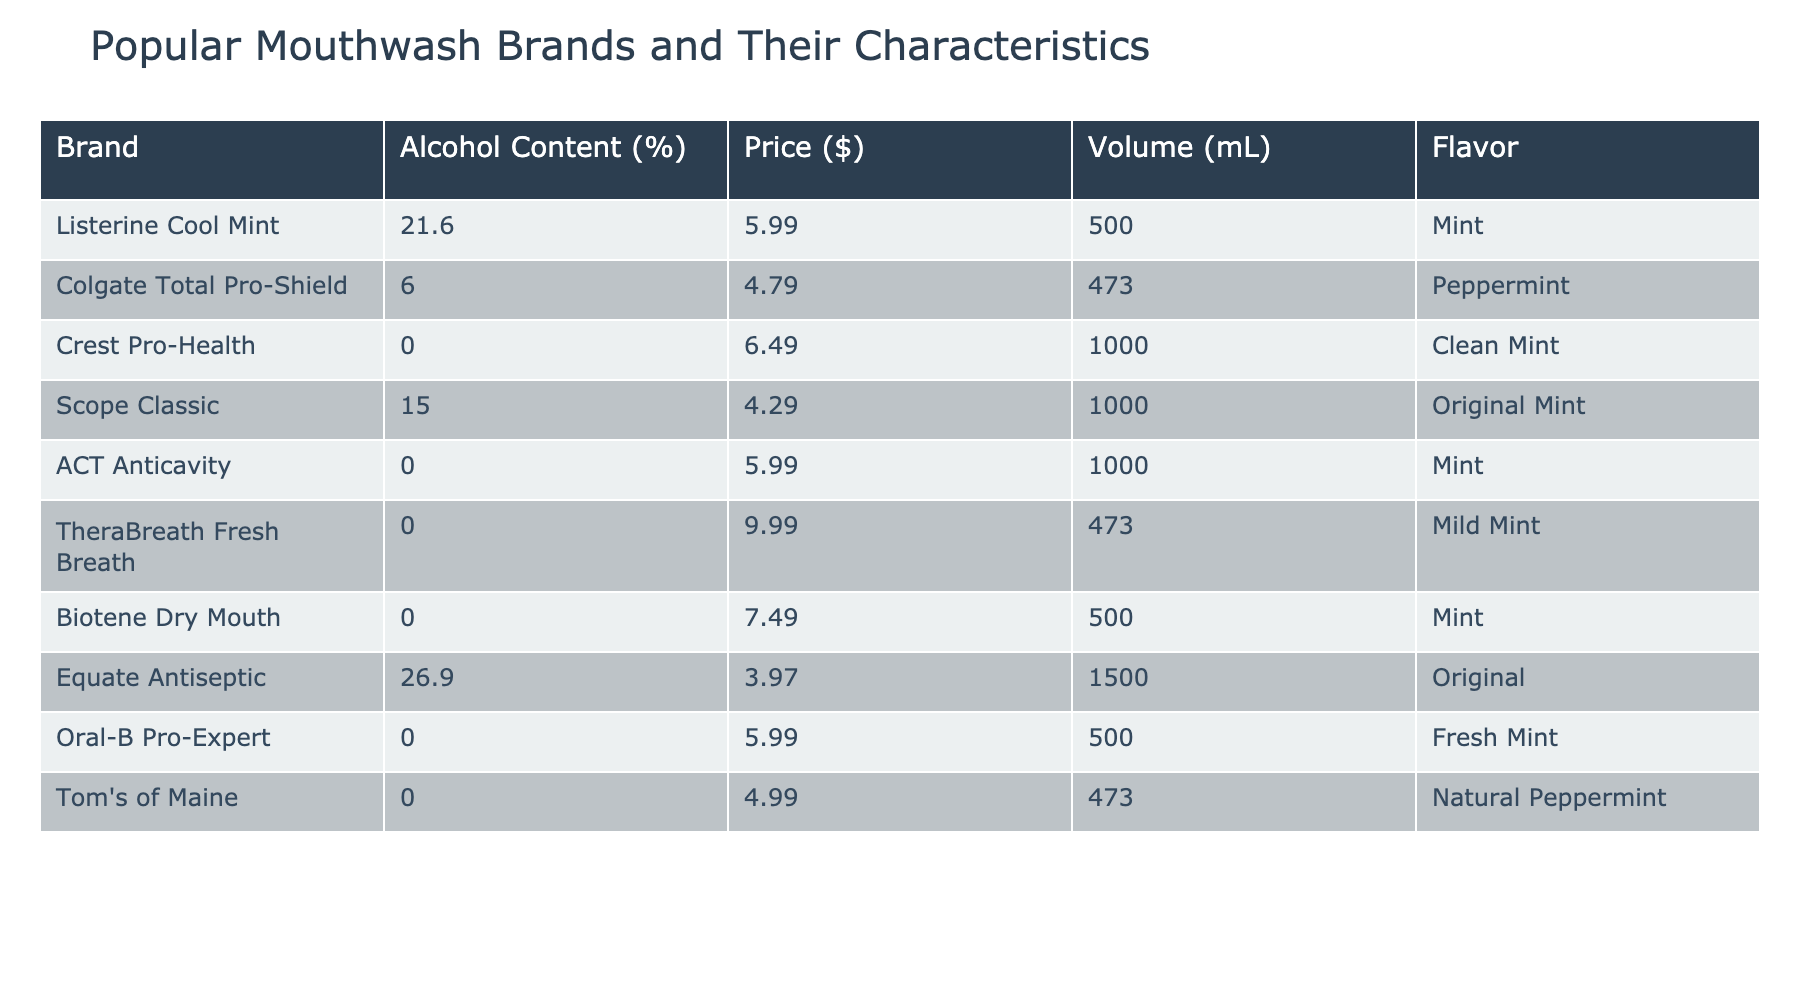What is the alcohol content of Listerine Cool Mint? The alcohol content is directly listed in the table for Listerine Cool Mint, which is 21.6%.
Answer: 21.6% Which mouthwash has the highest alcohol content? By comparing the alcohol content values in the table, Equate Antiseptic has the highest alcohol content at 26.9%.
Answer: Equate Antiseptic How many mouthwash brands have an alcohol content of 0%? The table lists mouthwashes with an alcohol content of 0%. They include Crest Pro-Health, ACT Anticavity, TheraBreath Fresh Breath, Biotene Dry Mouth, Oral-B Pro-Expert, and Tom's of Maine. Counting these, there are 6 brands.
Answer: 6 What is the average alcohol content of all listed mouthwashes? To find the average, add all the alcohol content values (21.6 + 6.0 + 0.0 + 15.0 + 0.0 + 0.0 + 0.0 + 26.9 + 0.0 + 0.0) which totals 69.5%, and divide by the number of brands (10), giving 69.5 / 10 = 6.95%.
Answer: 6.95% Is the price of Crest Pro-Health higher than that of Colgate Total Pro-Shield? The prices for Crest Pro-Health ($6.49) and Colgate Total Pro-Shield ($4.79) can be directly compared from the table. Crest Pro-Health is higher.
Answer: Yes What is the difference in price between Equate Antiseptic and Listerine Cool Mint? The price of Equate Antiseptic is $3.97 and Listerine Cool Mint is $5.99. The difference is $5.99 - $3.97 = $2.02.
Answer: $2.02 How many mL of mouthwash does the cheapest option provide? The cheapest mouthwash in the table, Equate Antiseptic, provides a volume of 1500 mL.
Answer: 1500 mL Which flavor is associated with the mouthwash that has the lowest price? Looking for the lowest price, Equate Antiseptic is the cheapest at $3.97, and it has the flavor "Original."
Answer: Original Do all flavored mouthwashes have some level of alcohol in them? Looking at the alcoholic content, several mouthwashes with flavors like Mint and Peppermint have 0% alcohol. Therefore, not all flavored mouthwashes have alcohol.
Answer: No What is the combined volume of mouthwash from all brands that have an alcohol content greater than 0%? The brands with alcohol greater than 0% are Listerine Cool Mint (500 mL), Scope Classic (1000 mL), Colgate Total Pro-Shield (473 mL), and Equate Antiseptic (1500 mL). Adding these gives: 500 + 1000 + 473 + 1500 = 3473 mL.
Answer: 3473 mL 